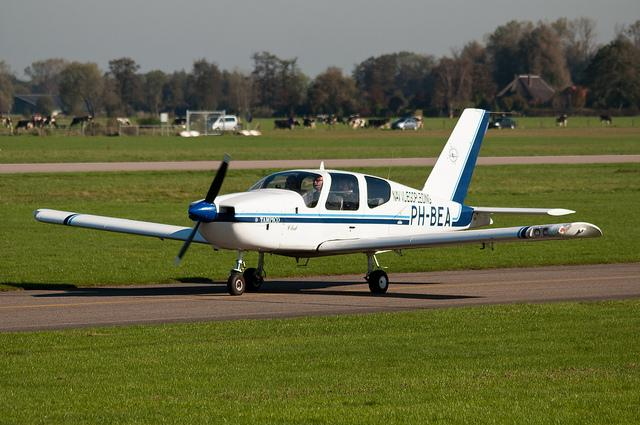What type of settlements are near the airport? Please explain your reasoning. farm. Lots of land that you can grow crops on. 